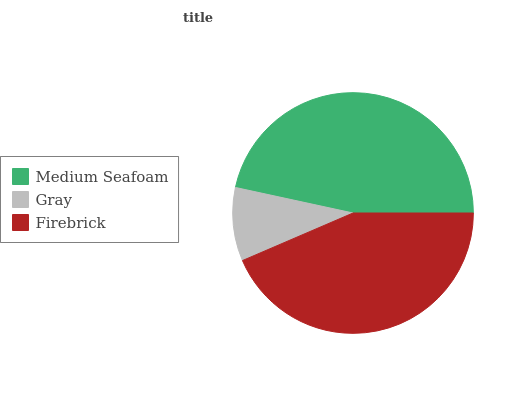Is Gray the minimum?
Answer yes or no. Yes. Is Medium Seafoam the maximum?
Answer yes or no. Yes. Is Firebrick the minimum?
Answer yes or no. No. Is Firebrick the maximum?
Answer yes or no. No. Is Firebrick greater than Gray?
Answer yes or no. Yes. Is Gray less than Firebrick?
Answer yes or no. Yes. Is Gray greater than Firebrick?
Answer yes or no. No. Is Firebrick less than Gray?
Answer yes or no. No. Is Firebrick the high median?
Answer yes or no. Yes. Is Firebrick the low median?
Answer yes or no. Yes. Is Gray the high median?
Answer yes or no. No. Is Medium Seafoam the low median?
Answer yes or no. No. 